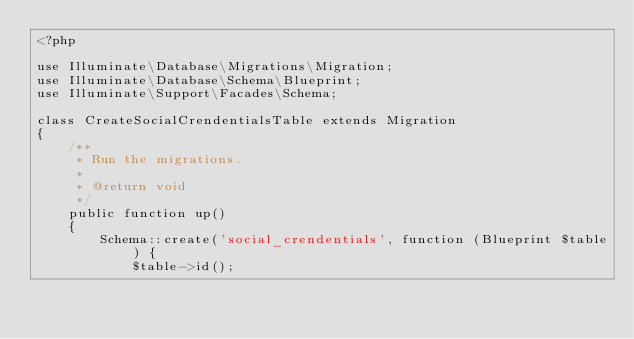Convert code to text. <code><loc_0><loc_0><loc_500><loc_500><_PHP_><?php

use Illuminate\Database\Migrations\Migration;
use Illuminate\Database\Schema\Blueprint;
use Illuminate\Support\Facades\Schema;

class CreateSocialCrendentialsTable extends Migration
{
    /**
     * Run the migrations.
     *
     * @return void
     */
    public function up()
    {
        Schema::create('social_crendentials', function (Blueprint $table) {
            $table->id();</code> 